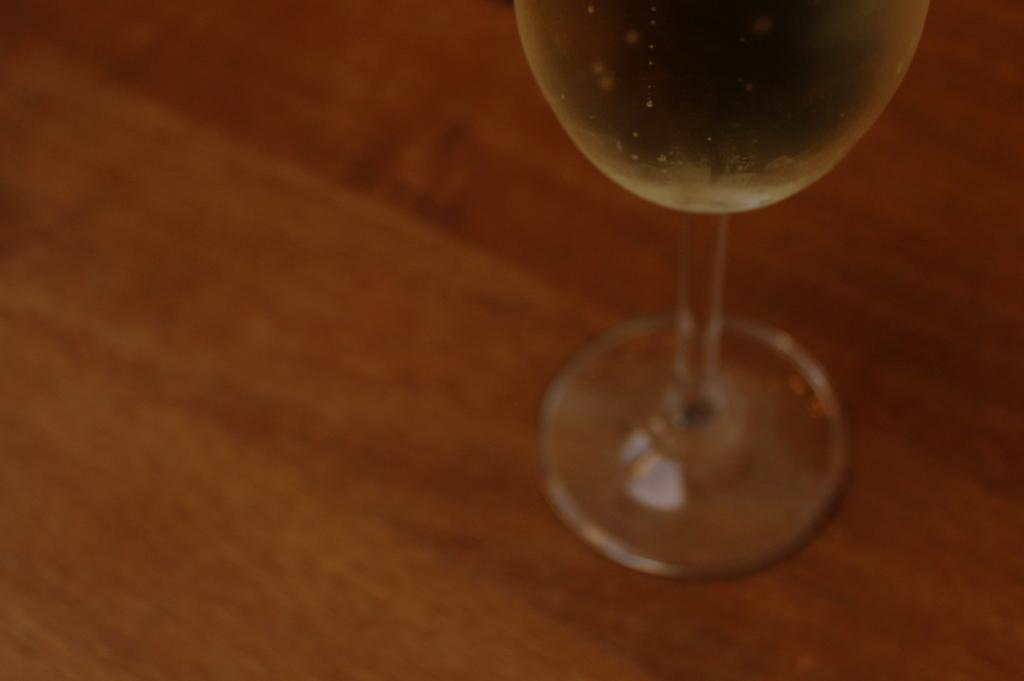What object is in the middle of the image? There is a glass in the middle of the image. What is the glass placed on in the image? The glass is on a wooden surface in the image. Can you describe the position of the glass in the image? The glass is in the middle of the image. What type of reading material is being discussed in the image? There is no reading material or discussion present in the image; it only features a glass on a wooden surface. 